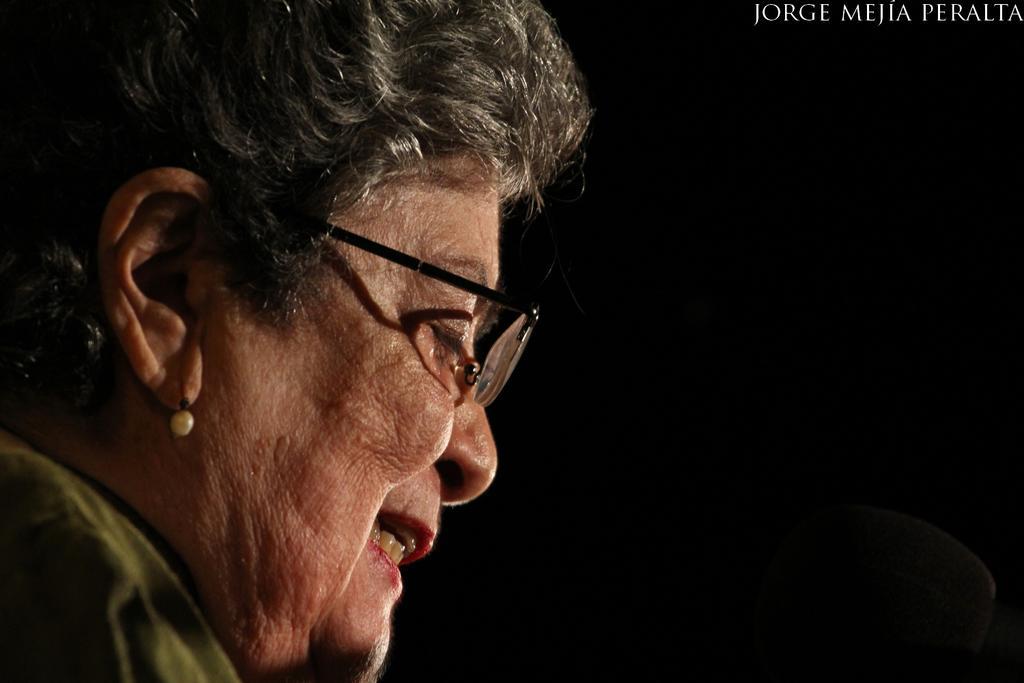Please provide a concise description of this image. There is a person wore spectacle. In the background it is dark. In the top right side of the image we can see text. 